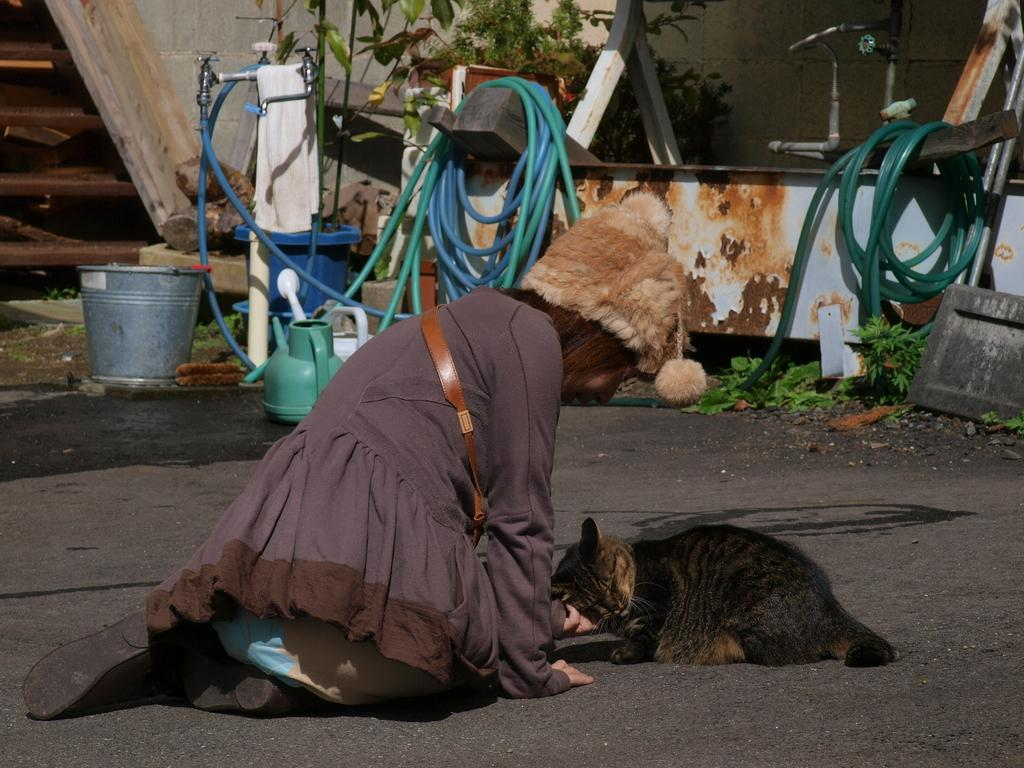What is the woman doing in the image? The woman is sitting on the ground in the foreground of the image. What is in front of the woman? There is a cat in front of the woman. What can be seen in the background of the image? In the background, there are pipes, tubs, a tap, a tree, a plant, and a wall visible. What type of brass instrument is the woman playing in the image? There is no brass instrument present in the image; the woman is sitting on the ground with a cat in front of her. 